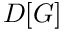<formula> <loc_0><loc_0><loc_500><loc_500>D [ G ]</formula> 